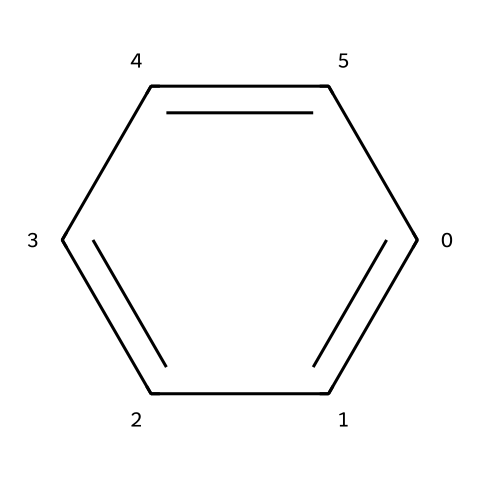What is the molecular formula of this compound? The SMILES representation indicates a structure with six carbons (C) and six hydrogens (H), corresponding to the molecular formula C6H6.
Answer: C6H6 How many carbon atoms are in benzene? The SMILES structure shows a total of six carbon atoms (C), which are the vertices of the hexagonal ring.
Answer: 6 What type of hybridization do the carbon atoms in benzene exhibit? Each carbon atom in the benzene ring is sp2 hybridized, which is evident from the planar arrangement and the presence of double bonds between the carbons.
Answer: sp2 Is benzene a saturated or unsaturated compound? Benzene contains alternating double bonds, indicating it has unsaturation; hence, it is classified as an unsaturated compound.
Answer: unsaturated What type of chemical bonding is primarily present in benzene? The structure shows that the carbon atoms are connected by sigma (σ) bonds and delocalized pi (π) bonds, characteristic of aromatic compounds.
Answer: aromatic What is a key property of aromatic compounds like benzene? Aromatic compounds, including benzene, are notable for their stability and unique reactivity due to resonance stabilization and the presence of a conjugated pi-electron system.
Answer: stability 